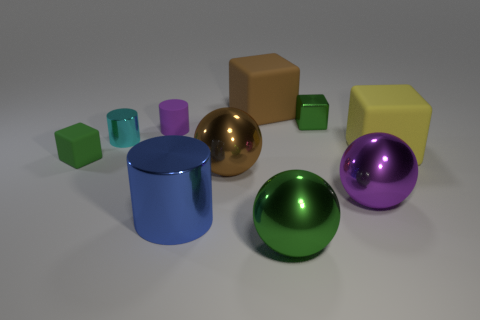What shape is the large brown object that is made of the same material as the big blue cylinder?
Your answer should be compact. Sphere. Do the large cylinder and the sphere on the left side of the large brown matte cube have the same material?
Provide a short and direct response. Yes. Is there a big metallic thing that is behind the green thing on the left side of the small cyan object?
Offer a terse response. No. There is a purple thing that is the same shape as the cyan object; what material is it?
Provide a short and direct response. Rubber. There is a matte object on the right side of the large brown rubber cube; how many large things are left of it?
Your answer should be compact. 5. Are there any other things of the same color as the large cylinder?
Ensure brevity in your answer.  No. What number of things are either big yellow cubes or cylinders behind the purple metal object?
Offer a terse response. 3. The small green block that is in front of the small metallic object that is to the left of the shiny cylinder that is on the right side of the tiny purple rubber thing is made of what material?
Provide a short and direct response. Rubber. What size is the brown ball that is made of the same material as the tiny cyan cylinder?
Your answer should be very brief. Large. There is a tiny metallic thing left of the green shiny object in front of the green matte block; what color is it?
Make the answer very short. Cyan. 